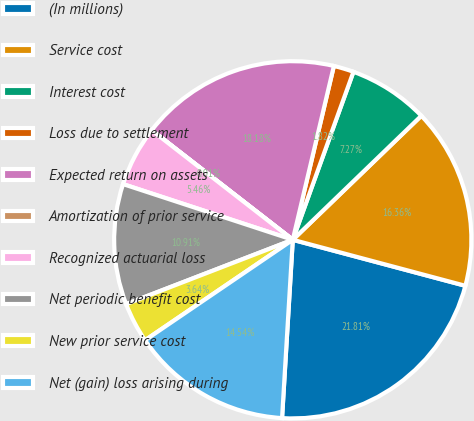<chart> <loc_0><loc_0><loc_500><loc_500><pie_chart><fcel>(In millions)<fcel>Service cost<fcel>Interest cost<fcel>Loss due to settlement<fcel>Expected return on assets<fcel>Amortization of prior service<fcel>Recognized actuarial loss<fcel>Net periodic benefit cost<fcel>New prior service cost<fcel>Net (gain) loss arising during<nl><fcel>21.81%<fcel>16.36%<fcel>7.27%<fcel>1.82%<fcel>18.18%<fcel>0.01%<fcel>5.46%<fcel>10.91%<fcel>3.64%<fcel>14.54%<nl></chart> 